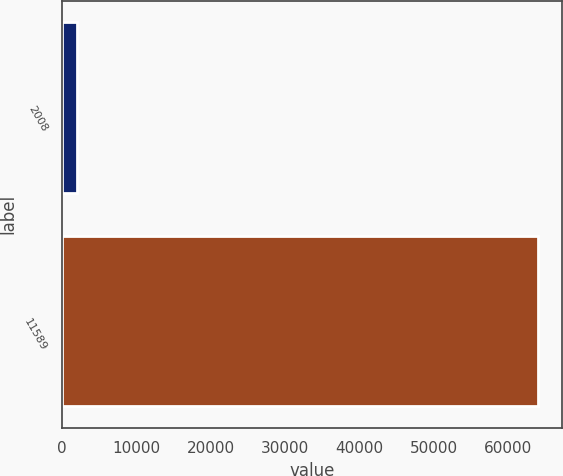Convert chart. <chart><loc_0><loc_0><loc_500><loc_500><bar_chart><fcel>2008<fcel>11589<nl><fcel>2005<fcel>64011<nl></chart> 